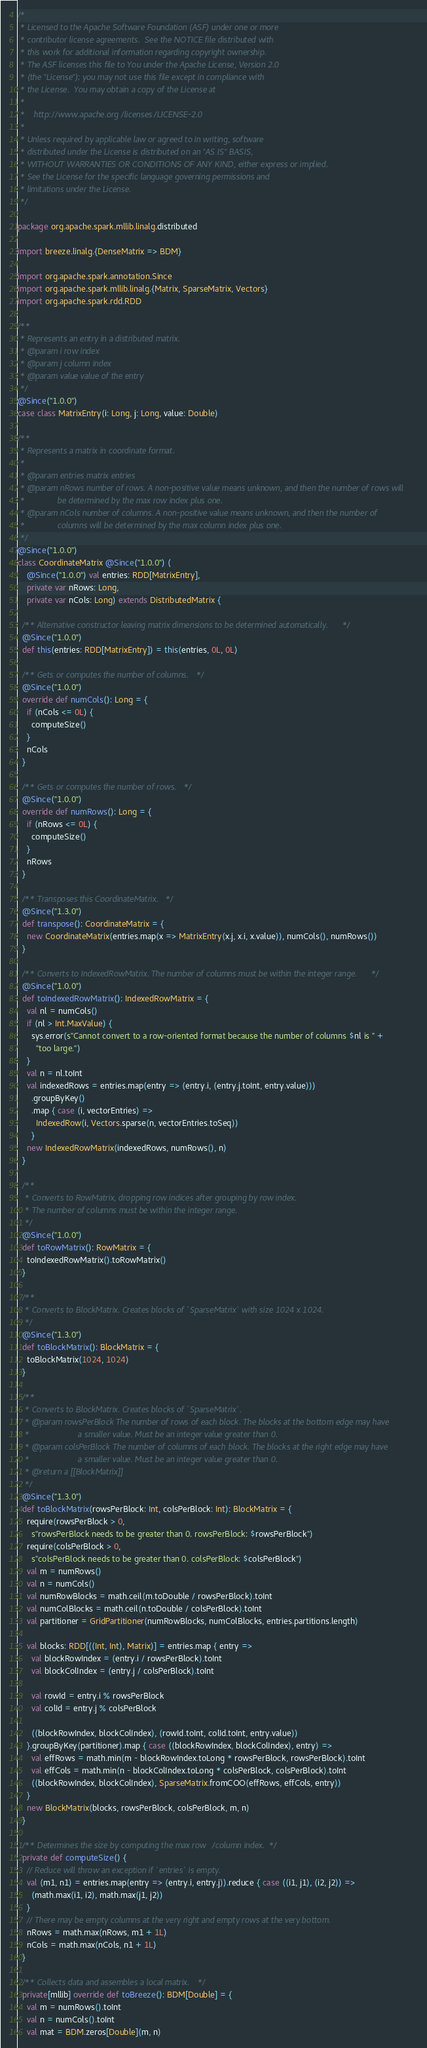Convert code to text. <code><loc_0><loc_0><loc_500><loc_500><_Scala_>/*
 * Licensed to the Apache Software Foundation (ASF) under one or more
 * contributor license agreements.  See the NOTICE file distributed with
 * this work for additional information regarding copyright ownership.
 * The ASF licenses this file to You under the Apache License, Version 2.0
 * (the "License"); you may not use this file except in compliance with
 * the License.  You may obtain a copy of the License at
 *
 *    http://www.apache.org/licenses/LICENSE-2.0
 *
 * Unless required by applicable law or agreed to in writing, software
 * distributed under the License is distributed on an "AS IS" BASIS,
 * WITHOUT WARRANTIES OR CONDITIONS OF ANY KIND, either express or implied.
 * See the License for the specific language governing permissions and
 * limitations under the License.
 */

package org.apache.spark.mllib.linalg.distributed

import breeze.linalg.{DenseMatrix => BDM}

import org.apache.spark.annotation.Since
import org.apache.spark.mllib.linalg.{Matrix, SparseMatrix, Vectors}
import org.apache.spark.rdd.RDD

/**
 * Represents an entry in a distributed matrix.
 * @param i row index
 * @param j column index
 * @param value value of the entry
 */
@Since("1.0.0")
case class MatrixEntry(i: Long, j: Long, value: Double)

/**
 * Represents a matrix in coordinate format.
 *
 * @param entries matrix entries
 * @param nRows number of rows. A non-positive value means unknown, and then the number of rows will
 *              be determined by the max row index plus one.
 * @param nCols number of columns. A non-positive value means unknown, and then the number of
 *              columns will be determined by the max column index plus one.
 */
@Since("1.0.0")
class CoordinateMatrix @Since("1.0.0") (
    @Since("1.0.0") val entries: RDD[MatrixEntry],
    private var nRows: Long,
    private var nCols: Long) extends DistributedMatrix {

  /** Alternative constructor leaving matrix dimensions to be determined automatically. */
  @Since("1.0.0")
  def this(entries: RDD[MatrixEntry]) = this(entries, 0L, 0L)

  /** Gets or computes the number of columns. */
  @Since("1.0.0")
  override def numCols(): Long = {
    if (nCols <= 0L) {
      computeSize()
    }
    nCols
  }

  /** Gets or computes the number of rows. */
  @Since("1.0.0")
  override def numRows(): Long = {
    if (nRows <= 0L) {
      computeSize()
    }
    nRows
  }

  /** Transposes this CoordinateMatrix. */
  @Since("1.3.0")
  def transpose(): CoordinateMatrix = {
    new CoordinateMatrix(entries.map(x => MatrixEntry(x.j, x.i, x.value)), numCols(), numRows())
  }

  /** Converts to IndexedRowMatrix. The number of columns must be within the integer range. */
  @Since("1.0.0")
  def toIndexedRowMatrix(): IndexedRowMatrix = {
    val nl = numCols()
    if (nl > Int.MaxValue) {
      sys.error(s"Cannot convert to a row-oriented format because the number of columns $nl is " +
        "too large.")
    }
    val n = nl.toInt
    val indexedRows = entries.map(entry => (entry.i, (entry.j.toInt, entry.value)))
      .groupByKey()
      .map { case (i, vectorEntries) =>
        IndexedRow(i, Vectors.sparse(n, vectorEntries.toSeq))
      }
    new IndexedRowMatrix(indexedRows, numRows(), n)
  }

  /**
   * Converts to RowMatrix, dropping row indices after grouping by row index.
   * The number of columns must be within the integer range.
   */
  @Since("1.0.0")
  def toRowMatrix(): RowMatrix = {
    toIndexedRowMatrix().toRowMatrix()
  }

  /**
   * Converts to BlockMatrix. Creates blocks of `SparseMatrix` with size 1024 x 1024.
   */
  @Since("1.3.0")
  def toBlockMatrix(): BlockMatrix = {
    toBlockMatrix(1024, 1024)
  }

  /**
   * Converts to BlockMatrix. Creates blocks of `SparseMatrix`.
   * @param rowsPerBlock The number of rows of each block. The blocks at the bottom edge may have
   *                     a smaller value. Must be an integer value greater than 0.
   * @param colsPerBlock The number of columns of each block. The blocks at the right edge may have
   *                     a smaller value. Must be an integer value greater than 0.
   * @return a [[BlockMatrix]]
   */
  @Since("1.3.0")
  def toBlockMatrix(rowsPerBlock: Int, colsPerBlock: Int): BlockMatrix = {
    require(rowsPerBlock > 0,
      s"rowsPerBlock needs to be greater than 0. rowsPerBlock: $rowsPerBlock")
    require(colsPerBlock > 0,
      s"colsPerBlock needs to be greater than 0. colsPerBlock: $colsPerBlock")
    val m = numRows()
    val n = numCols()
    val numRowBlocks = math.ceil(m.toDouble / rowsPerBlock).toInt
    val numColBlocks = math.ceil(n.toDouble / colsPerBlock).toInt
    val partitioner = GridPartitioner(numRowBlocks, numColBlocks, entries.partitions.length)

    val blocks: RDD[((Int, Int), Matrix)] = entries.map { entry =>
      val blockRowIndex = (entry.i / rowsPerBlock).toInt
      val blockColIndex = (entry.j / colsPerBlock).toInt

      val rowId = entry.i % rowsPerBlock
      val colId = entry.j % colsPerBlock

      ((blockRowIndex, blockColIndex), (rowId.toInt, colId.toInt, entry.value))
    }.groupByKey(partitioner).map { case ((blockRowIndex, blockColIndex), entry) =>
      val effRows = math.min(m - blockRowIndex.toLong * rowsPerBlock, rowsPerBlock).toInt
      val effCols = math.min(n - blockColIndex.toLong * colsPerBlock, colsPerBlock).toInt
      ((blockRowIndex, blockColIndex), SparseMatrix.fromCOO(effRows, effCols, entry))
    }
    new BlockMatrix(blocks, rowsPerBlock, colsPerBlock, m, n)
  }

  /** Determines the size by computing the max row/column index. */
  private def computeSize() {
    // Reduce will throw an exception if `entries` is empty.
    val (m1, n1) = entries.map(entry => (entry.i, entry.j)).reduce { case ((i1, j1), (i2, j2)) =>
      (math.max(i1, i2), math.max(j1, j2))
    }
    // There may be empty columns at the very right and empty rows at the very bottom.
    nRows = math.max(nRows, m1 + 1L)
    nCols = math.max(nCols, n1 + 1L)
  }

  /** Collects data and assembles a local matrix. */
  private[mllib] override def toBreeze(): BDM[Double] = {
    val m = numRows().toInt
    val n = numCols().toInt
    val mat = BDM.zeros[Double](m, n)</code> 